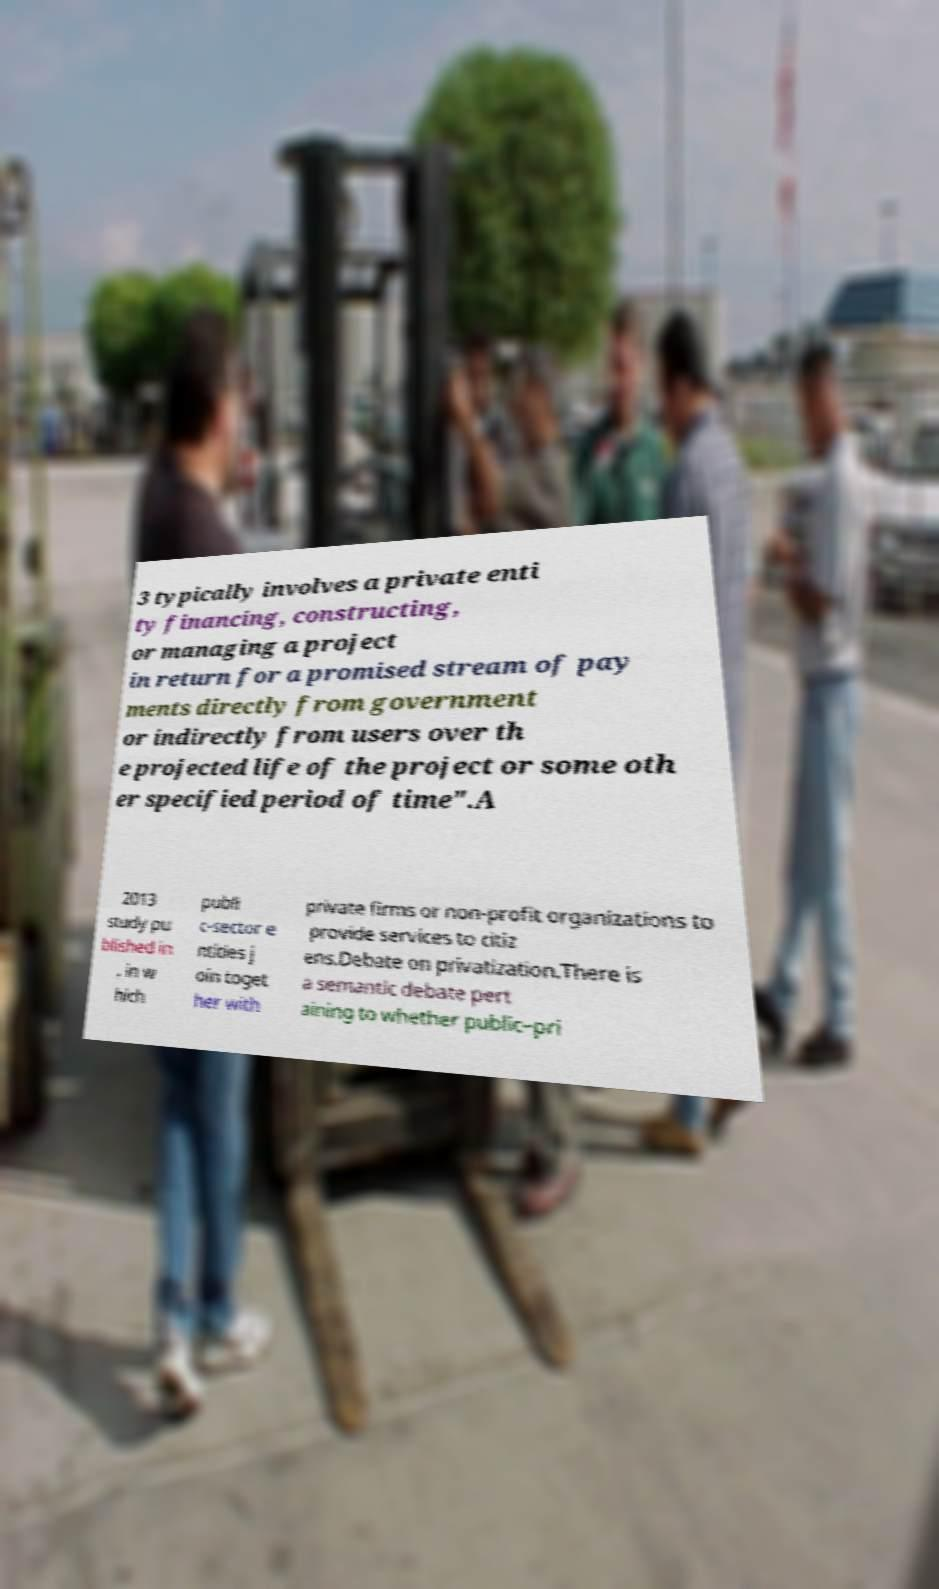I need the written content from this picture converted into text. Can you do that? 3 typically involves a private enti ty financing, constructing, or managing a project in return for a promised stream of pay ments directly from government or indirectly from users over th e projected life of the project or some oth er specified period of time".A 2013 study pu blished in , in w hich publi c-sector e ntities j oin toget her with private firms or non-profit organizations to provide services to citiz ens.Debate on privatization.There is a semantic debate pert aining to whether public–pri 